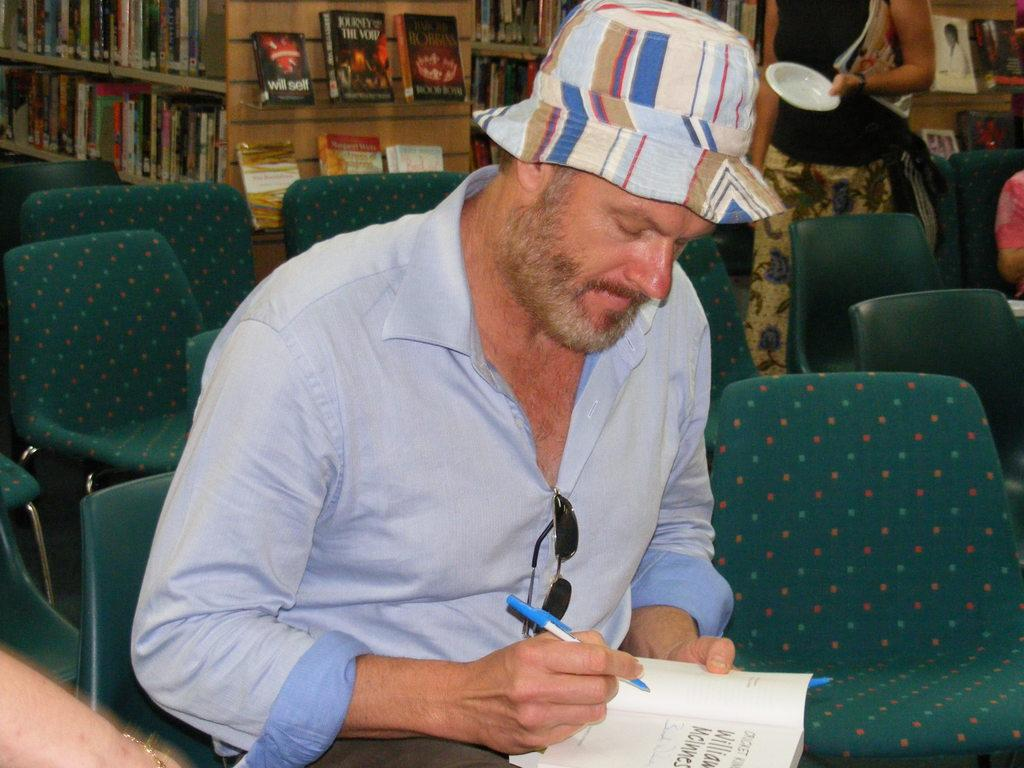What is the man in the image doing? The man is sitting on a chair in the image. Can you describe the setting in the image? There are multiple chairs and books visible in the background of the image, along with people. How many chairs can be seen in the image? There is one chair that the man is sitting on, and multiple chairs in the background. What type of ball is being used for payment in the image? There is no ball or payment transaction present in the image. How many matches are visible in the image? There are no matches visible in the image. 